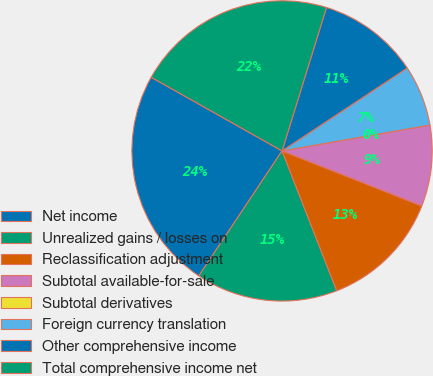Convert chart to OTSL. <chart><loc_0><loc_0><loc_500><loc_500><pie_chart><fcel>Net income<fcel>Unrealized gains / losses on<fcel>Reclassification adjustment<fcel>Subtotal available-for-sale<fcel>Subtotal derivatives<fcel>Foreign currency translation<fcel>Other comprehensive income<fcel>Total comprehensive income net<nl><fcel>23.81%<fcel>15.28%<fcel>13.09%<fcel>8.73%<fcel>0.0%<fcel>6.55%<fcel>10.91%<fcel>21.62%<nl></chart> 